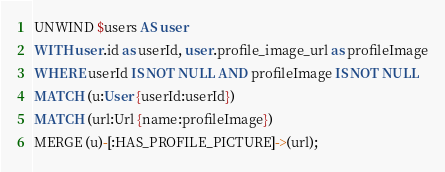<code> <loc_0><loc_0><loc_500><loc_500><_SQL_>UNWIND $users AS user
WITH user.id as userId, user.profile_image_url as profileImage
WHERE userId IS NOT NULL AND profileImage IS NOT NULL
MATCH (u:User {userId:userId})
MATCH (url:Url {name:profileImage})
MERGE (u)-[:HAS_PROFILE_PICTURE]->(url);
</code> 